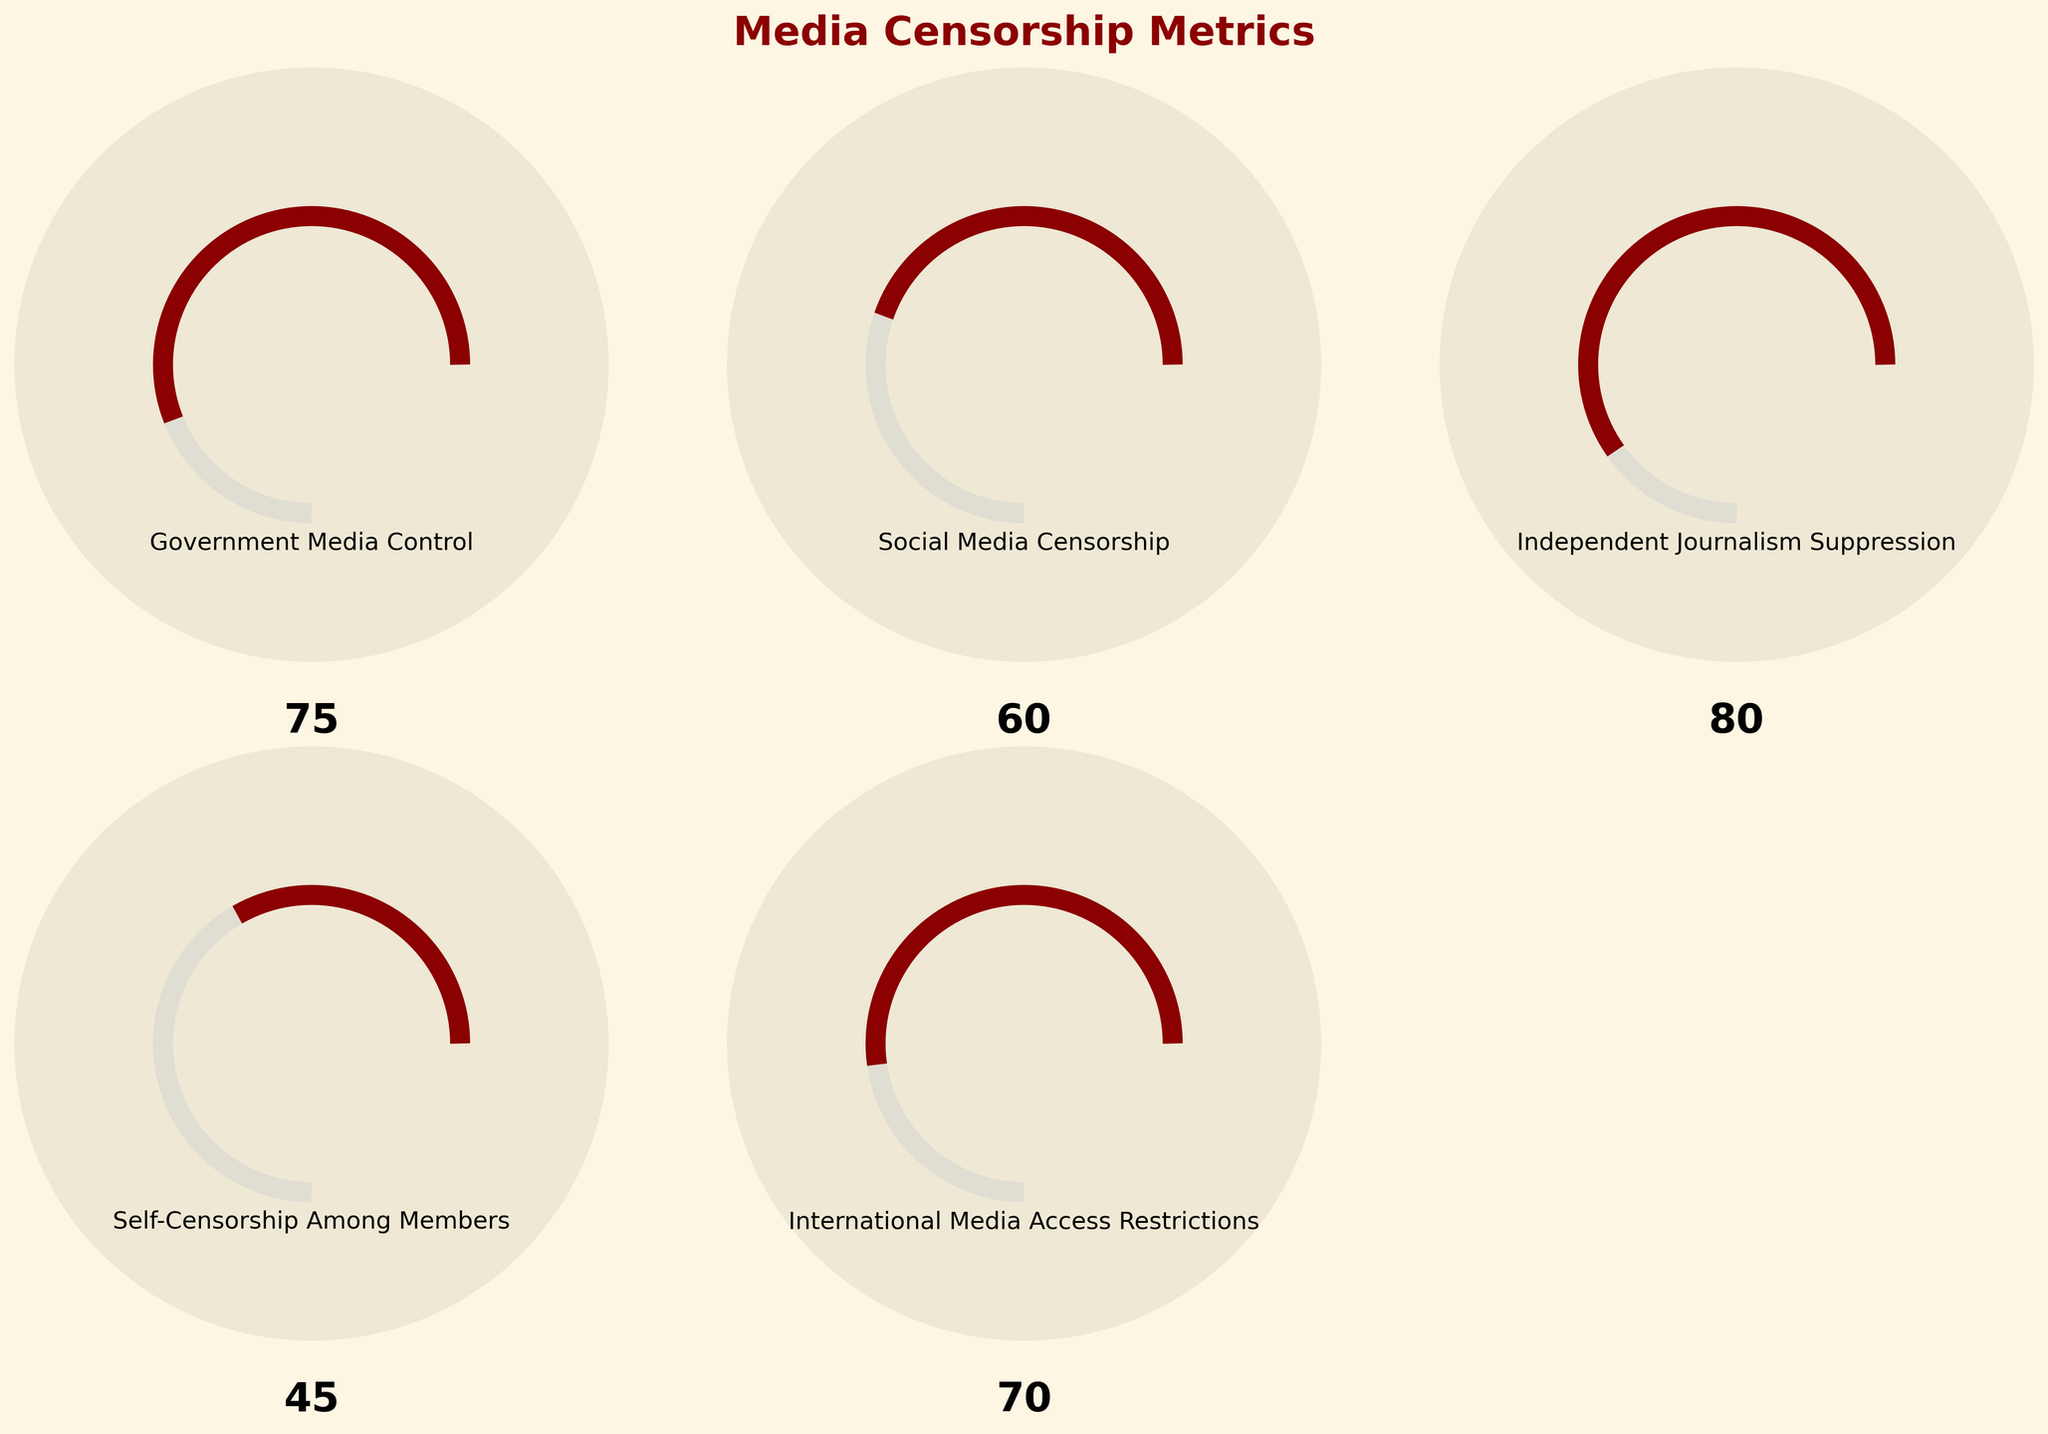What is the title of the figure? The title of the figure is located at the top and provides an overview of the content.
Answer: Media Censorship Metrics What is the normalized value of Social Media Censorship? To find the normalized value, we take the actual value (60) and calculate the proportion between the minimum (0) and maximum (100). The formula is (60 - 0) / (100 - 0), which results in 0.6.
Answer: 0.6 Which category has the highest degree of censorship? By looking at the values on the gauges, we identify the largest number. Independent Journalism Suppression has the highest value at 80.
Answer: Independent Journalism Suppression How much lower is Self-Censorship Among Members compared to Independent Journalism Suppression? The value for Self-Censorship Among Members is 45, and the value for Independent Journalism Suppression is 80. The difference is 80 - 45, which equals 35.
Answer: 35 What is the average value across all metrics? Sum all the values (75 + 60 + 80 + 45 + 70), resulting in 330. Then, divide by the number of metrics (5). The average is 330 / 5 = 66.
Answer: 66 Which metric has the lowest degree of censorship? By comparing the values on the gauges, we find that Self-Censorship Among Members has the lowest value, which is 45.
Answer: Self-Censorship Among Members What color is used to indicate the degree of censorship? The color used to indicate the degree of censorship is consistent across all the gauges. The color is a shade of dark red.
Answer: Dark red Is the value for Government Media Control closer to the minimum or maximum value of its range? The value for Government Media Control is 75. It is closer to the maximum value (100) than the minimum value (0).
Answer: Maximum What is the combined censorship value for Government Media Control and Social Media Censorship? Add the values for Government Media Control (75) and Social Media Censorship (60). The combined value is 75 + 60 = 135.
Answer: 135 